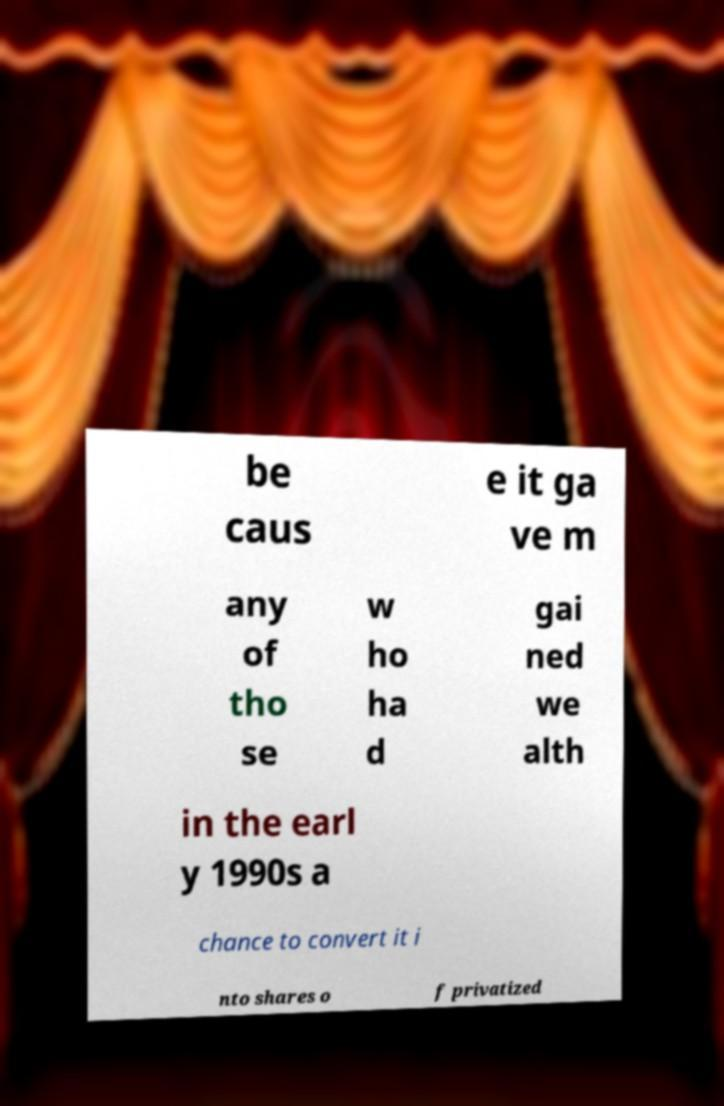For documentation purposes, I need the text within this image transcribed. Could you provide that? be caus e it ga ve m any of tho se w ho ha d gai ned we alth in the earl y 1990s a chance to convert it i nto shares o f privatized 